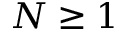Convert formula to latex. <formula><loc_0><loc_0><loc_500><loc_500>N \geq 1</formula> 